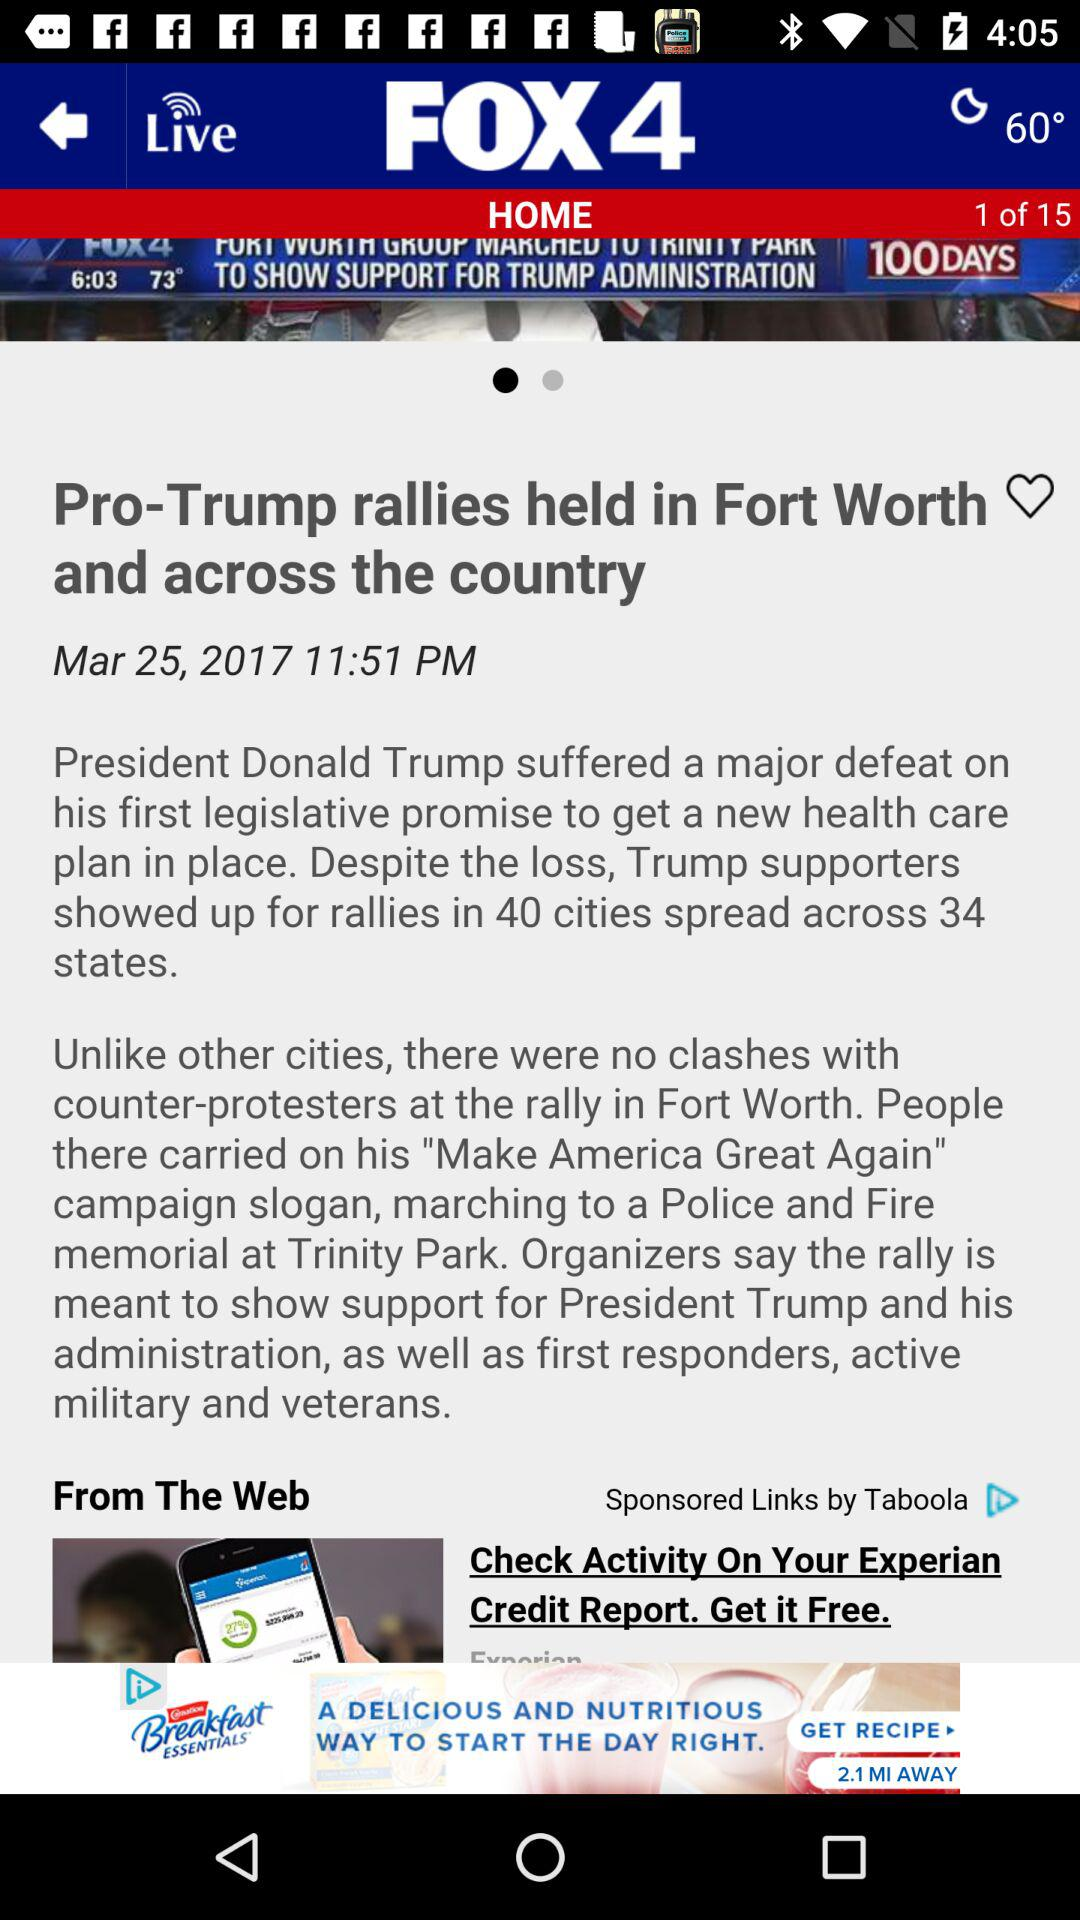At what time was the article posted? The article was posted at 11:51 PM. 